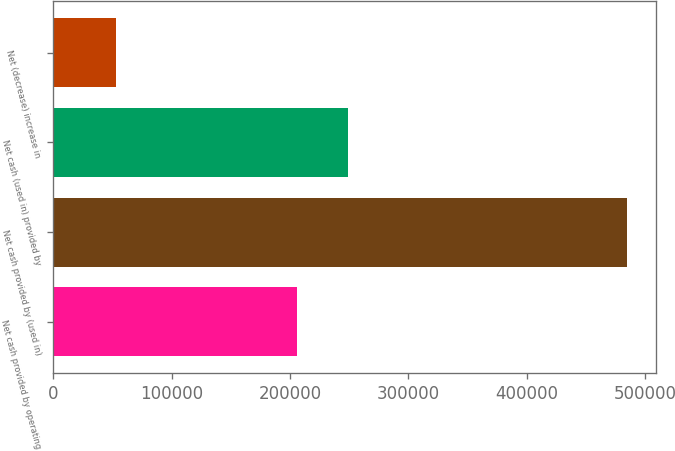Convert chart. <chart><loc_0><loc_0><loc_500><loc_500><bar_chart><fcel>Net cash provided by operating<fcel>Net cash provided by (used in)<fcel>Net cash (used in) provided by<fcel>Net (decrease) increase in<nl><fcel>205403<fcel>484778<fcel>248595<fcel>52862<nl></chart> 